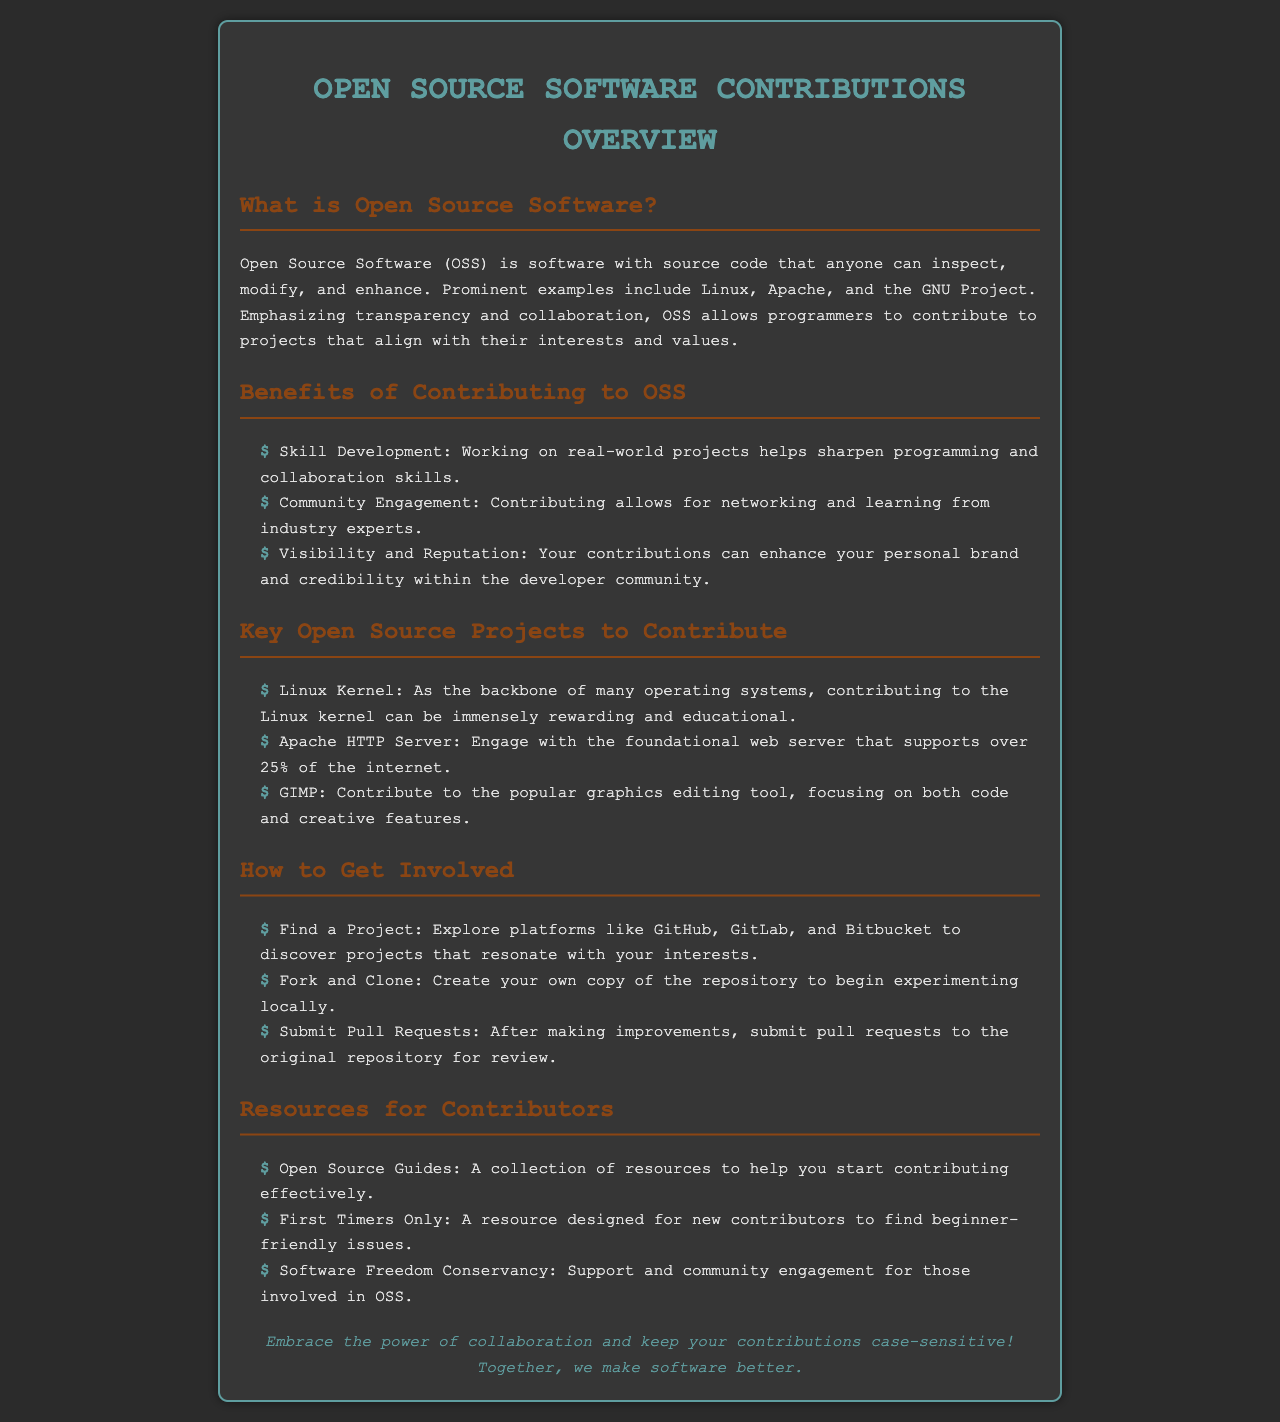What is Open Source Software? Open Source Software (OSS) is defined in the document as software with source code that anyone can inspect, modify, and enhance.
Answer: software with source code that anyone can inspect, modify, and enhance What are the benefits of contributing to OSS? The document lists three benefits: Skill Development, Community Engagement, and Visibility and Reputation.
Answer: Skill Development, Community Engagement, Visibility and Reputation Name a key open source project to contribute to. The brochure mentions three key projects, and one example is provided for readers to consider contributing.
Answer: Linux Kernel What should you do after finding a project? The document suggests a series of steps to get involved in a project, one of which is forking and cloning.
Answer: Fork and Clone What does the footer of the document promote? The footer highlights the importance of collaboration and keeping contributions case-sensitive, which is unique to open source culture.
Answer: Embrace the power of collaboration and keep your contributions case-sensitive! 